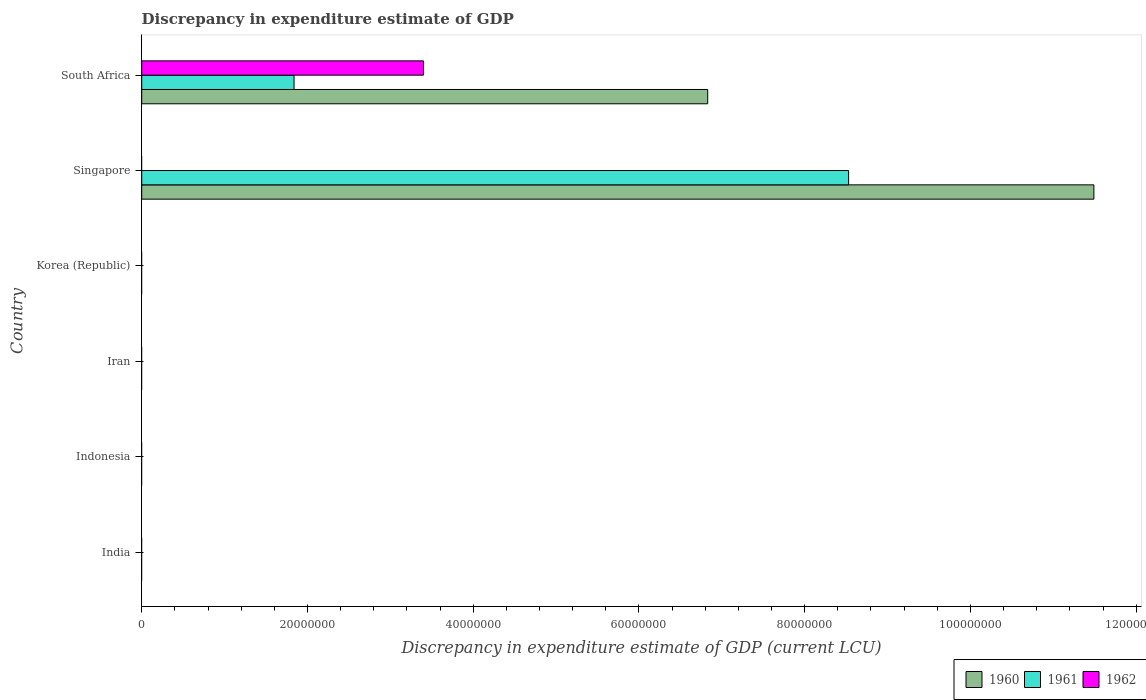How many different coloured bars are there?
Keep it short and to the point. 3. Are the number of bars per tick equal to the number of legend labels?
Your answer should be very brief. No. How many bars are there on the 4th tick from the bottom?
Make the answer very short. 0. What is the label of the 4th group of bars from the top?
Your answer should be compact. Iran. What is the discrepancy in expenditure estimate of GDP in 1961 in Singapore?
Keep it short and to the point. 8.53e+07. Across all countries, what is the maximum discrepancy in expenditure estimate of GDP in 1960?
Provide a succinct answer. 1.15e+08. In which country was the discrepancy in expenditure estimate of GDP in 1961 maximum?
Ensure brevity in your answer.  Singapore. What is the total discrepancy in expenditure estimate of GDP in 1962 in the graph?
Provide a short and direct response. 3.40e+07. What is the difference between the discrepancy in expenditure estimate of GDP in 1961 in Singapore and that in South Africa?
Give a very brief answer. 6.69e+07. What is the difference between the discrepancy in expenditure estimate of GDP in 1962 in India and the discrepancy in expenditure estimate of GDP in 1960 in Indonesia?
Give a very brief answer. 0. What is the average discrepancy in expenditure estimate of GDP in 1960 per country?
Keep it short and to the point. 3.05e+07. What is the difference between the discrepancy in expenditure estimate of GDP in 1961 and discrepancy in expenditure estimate of GDP in 1960 in Singapore?
Provide a succinct answer. -2.96e+07. What is the difference between the highest and the lowest discrepancy in expenditure estimate of GDP in 1961?
Your response must be concise. 8.53e+07. In how many countries, is the discrepancy in expenditure estimate of GDP in 1960 greater than the average discrepancy in expenditure estimate of GDP in 1960 taken over all countries?
Offer a very short reply. 2. How many bars are there?
Keep it short and to the point. 5. Are all the bars in the graph horizontal?
Your response must be concise. Yes. Are the values on the major ticks of X-axis written in scientific E-notation?
Ensure brevity in your answer.  No. Where does the legend appear in the graph?
Offer a terse response. Bottom right. How many legend labels are there?
Give a very brief answer. 3. How are the legend labels stacked?
Offer a terse response. Horizontal. What is the title of the graph?
Provide a short and direct response. Discrepancy in expenditure estimate of GDP. What is the label or title of the X-axis?
Your answer should be very brief. Discrepancy in expenditure estimate of GDP (current LCU). What is the Discrepancy in expenditure estimate of GDP (current LCU) of 1960 in India?
Provide a short and direct response. 0. What is the Discrepancy in expenditure estimate of GDP (current LCU) of 1961 in India?
Your response must be concise. 0. What is the Discrepancy in expenditure estimate of GDP (current LCU) of 1962 in India?
Your answer should be very brief. 0. What is the Discrepancy in expenditure estimate of GDP (current LCU) of 1961 in Indonesia?
Provide a succinct answer. 0. What is the Discrepancy in expenditure estimate of GDP (current LCU) of 1961 in Iran?
Keep it short and to the point. 0. What is the Discrepancy in expenditure estimate of GDP (current LCU) of 1960 in Singapore?
Your answer should be very brief. 1.15e+08. What is the Discrepancy in expenditure estimate of GDP (current LCU) in 1961 in Singapore?
Offer a very short reply. 8.53e+07. What is the Discrepancy in expenditure estimate of GDP (current LCU) of 1962 in Singapore?
Give a very brief answer. 0. What is the Discrepancy in expenditure estimate of GDP (current LCU) in 1960 in South Africa?
Your answer should be very brief. 6.83e+07. What is the Discrepancy in expenditure estimate of GDP (current LCU) in 1961 in South Africa?
Make the answer very short. 1.84e+07. What is the Discrepancy in expenditure estimate of GDP (current LCU) in 1962 in South Africa?
Provide a succinct answer. 3.40e+07. Across all countries, what is the maximum Discrepancy in expenditure estimate of GDP (current LCU) in 1960?
Your answer should be compact. 1.15e+08. Across all countries, what is the maximum Discrepancy in expenditure estimate of GDP (current LCU) of 1961?
Your answer should be very brief. 8.53e+07. Across all countries, what is the maximum Discrepancy in expenditure estimate of GDP (current LCU) of 1962?
Ensure brevity in your answer.  3.40e+07. Across all countries, what is the minimum Discrepancy in expenditure estimate of GDP (current LCU) in 1960?
Provide a succinct answer. 0. Across all countries, what is the minimum Discrepancy in expenditure estimate of GDP (current LCU) of 1961?
Your answer should be very brief. 0. What is the total Discrepancy in expenditure estimate of GDP (current LCU) of 1960 in the graph?
Make the answer very short. 1.83e+08. What is the total Discrepancy in expenditure estimate of GDP (current LCU) in 1961 in the graph?
Offer a very short reply. 1.04e+08. What is the total Discrepancy in expenditure estimate of GDP (current LCU) in 1962 in the graph?
Provide a short and direct response. 3.40e+07. What is the difference between the Discrepancy in expenditure estimate of GDP (current LCU) of 1960 in Singapore and that in South Africa?
Offer a terse response. 4.66e+07. What is the difference between the Discrepancy in expenditure estimate of GDP (current LCU) in 1961 in Singapore and that in South Africa?
Your answer should be very brief. 6.69e+07. What is the difference between the Discrepancy in expenditure estimate of GDP (current LCU) in 1960 in Singapore and the Discrepancy in expenditure estimate of GDP (current LCU) in 1961 in South Africa?
Provide a short and direct response. 9.65e+07. What is the difference between the Discrepancy in expenditure estimate of GDP (current LCU) of 1960 in Singapore and the Discrepancy in expenditure estimate of GDP (current LCU) of 1962 in South Africa?
Ensure brevity in your answer.  8.09e+07. What is the difference between the Discrepancy in expenditure estimate of GDP (current LCU) of 1961 in Singapore and the Discrepancy in expenditure estimate of GDP (current LCU) of 1962 in South Africa?
Provide a short and direct response. 5.13e+07. What is the average Discrepancy in expenditure estimate of GDP (current LCU) in 1960 per country?
Provide a succinct answer. 3.05e+07. What is the average Discrepancy in expenditure estimate of GDP (current LCU) of 1961 per country?
Your answer should be very brief. 1.73e+07. What is the average Discrepancy in expenditure estimate of GDP (current LCU) of 1962 per country?
Your answer should be very brief. 5.67e+06. What is the difference between the Discrepancy in expenditure estimate of GDP (current LCU) in 1960 and Discrepancy in expenditure estimate of GDP (current LCU) in 1961 in Singapore?
Your answer should be compact. 2.96e+07. What is the difference between the Discrepancy in expenditure estimate of GDP (current LCU) in 1960 and Discrepancy in expenditure estimate of GDP (current LCU) in 1961 in South Africa?
Provide a short and direct response. 4.99e+07. What is the difference between the Discrepancy in expenditure estimate of GDP (current LCU) of 1960 and Discrepancy in expenditure estimate of GDP (current LCU) of 1962 in South Africa?
Provide a succinct answer. 3.43e+07. What is the difference between the Discrepancy in expenditure estimate of GDP (current LCU) in 1961 and Discrepancy in expenditure estimate of GDP (current LCU) in 1962 in South Africa?
Ensure brevity in your answer.  -1.56e+07. What is the ratio of the Discrepancy in expenditure estimate of GDP (current LCU) in 1960 in Singapore to that in South Africa?
Offer a very short reply. 1.68. What is the ratio of the Discrepancy in expenditure estimate of GDP (current LCU) in 1961 in Singapore to that in South Africa?
Ensure brevity in your answer.  4.64. What is the difference between the highest and the lowest Discrepancy in expenditure estimate of GDP (current LCU) of 1960?
Your answer should be very brief. 1.15e+08. What is the difference between the highest and the lowest Discrepancy in expenditure estimate of GDP (current LCU) of 1961?
Your answer should be very brief. 8.53e+07. What is the difference between the highest and the lowest Discrepancy in expenditure estimate of GDP (current LCU) of 1962?
Your response must be concise. 3.40e+07. 